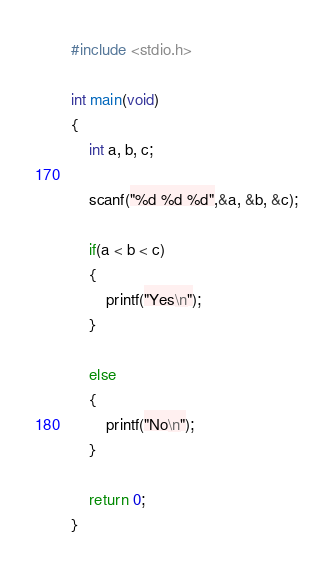<code> <loc_0><loc_0><loc_500><loc_500><_C_>#include <stdio.h> 

int main(void)
{
	int a, b, c;

	scanf("%d %d %d",&a, &b, &c);

	if(a < b < c)
	{
		printf("Yes\n");
	}
	
	else
	{
		printf("No\n");
	}
	
	return 0;
}</code> 